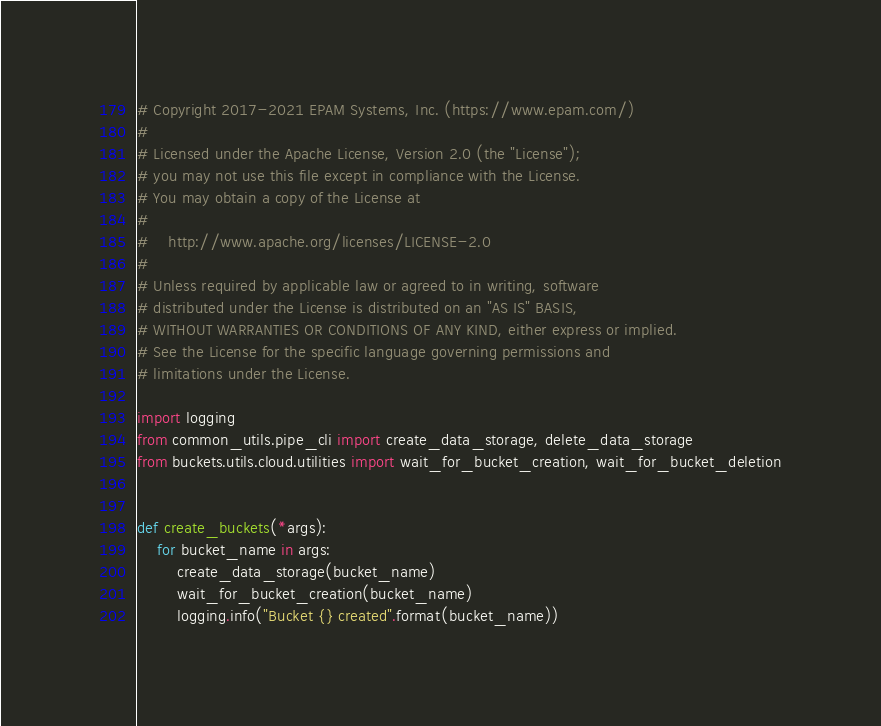<code> <loc_0><loc_0><loc_500><loc_500><_Python_># Copyright 2017-2021 EPAM Systems, Inc. (https://www.epam.com/)
#
# Licensed under the Apache License, Version 2.0 (the "License");
# you may not use this file except in compliance with the License.
# You may obtain a copy of the License at
#
#    http://www.apache.org/licenses/LICENSE-2.0
#
# Unless required by applicable law or agreed to in writing, software
# distributed under the License is distributed on an "AS IS" BASIS,
# WITHOUT WARRANTIES OR CONDITIONS OF ANY KIND, either express or implied.
# See the License for the specific language governing permissions and
# limitations under the License.

import logging
from common_utils.pipe_cli import create_data_storage, delete_data_storage
from buckets.utils.cloud.utilities import wait_for_bucket_creation, wait_for_bucket_deletion


def create_buckets(*args):
    for bucket_name in args:
        create_data_storage(bucket_name)
        wait_for_bucket_creation(bucket_name)
        logging.info("Bucket {} created".format(bucket_name))

</code> 